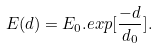Convert formula to latex. <formula><loc_0><loc_0><loc_500><loc_500>E ( d ) = E _ { 0 } . e x p [ \frac { - d } { d _ { 0 } } ] . \</formula> 